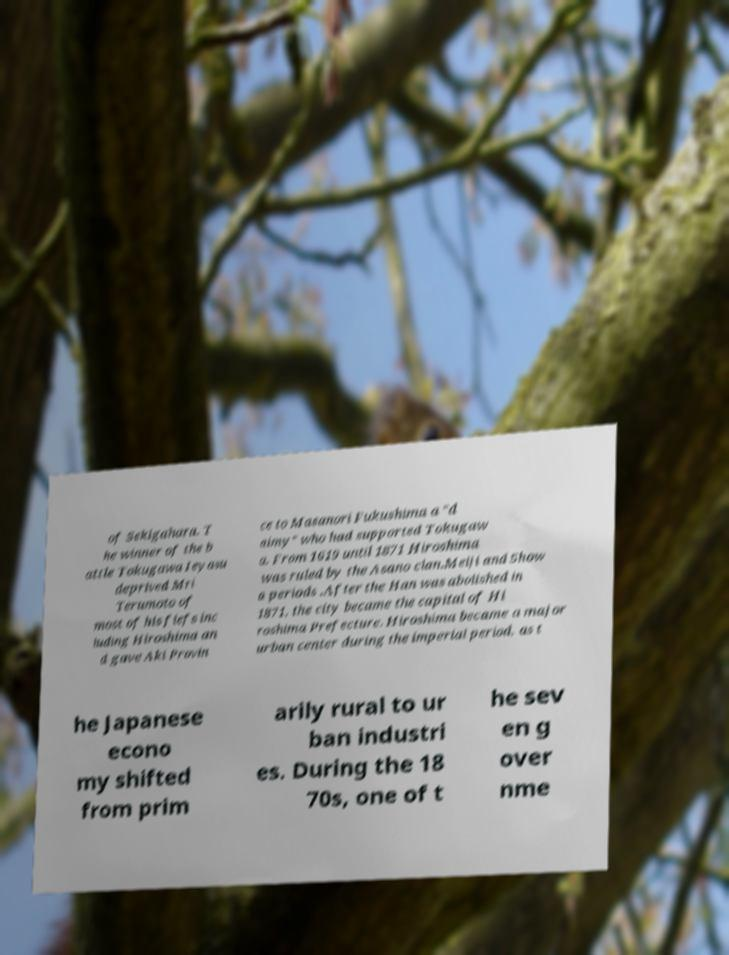What messages or text are displayed in this image? I need them in a readable, typed format. of Sekigahara. T he winner of the b attle Tokugawa Ieyasu deprived Mri Terumoto of most of his fiefs inc luding Hiroshima an d gave Aki Provin ce to Masanori Fukushima a "d aimy" who had supported Tokugaw a. From 1619 until 1871 Hiroshima was ruled by the Asano clan.Meiji and Show a periods .After the Han was abolished in 1871, the city became the capital of Hi roshima Prefecture. Hiroshima became a major urban center during the imperial period, as t he Japanese econo my shifted from prim arily rural to ur ban industri es. During the 18 70s, one of t he sev en g over nme 